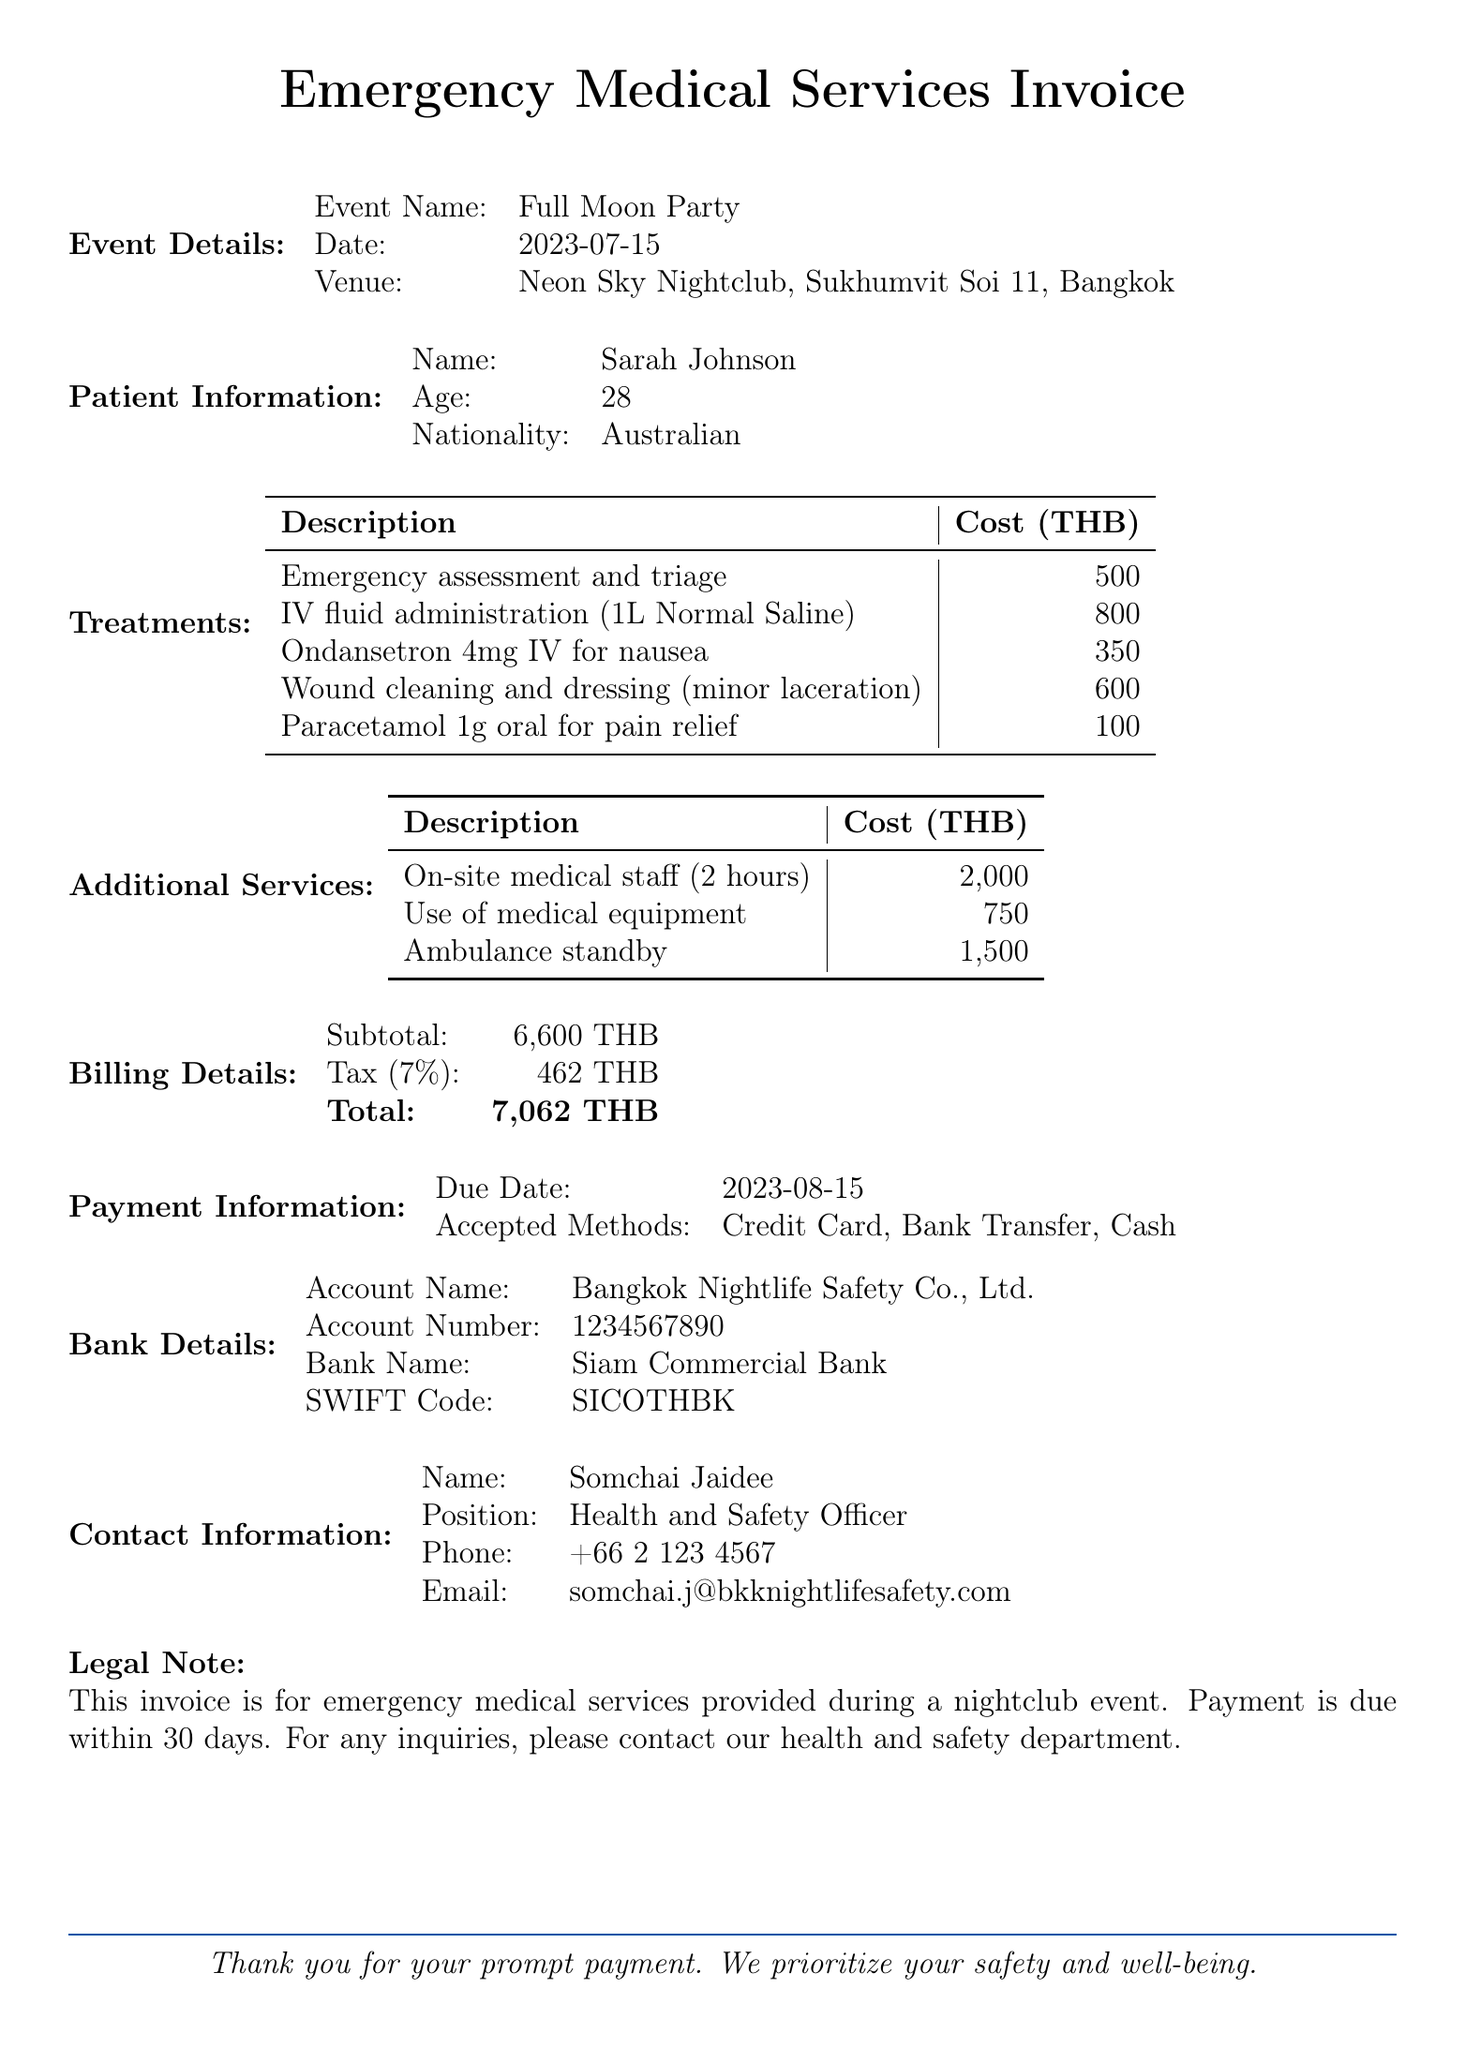What is the name of the event? The event name is specified in the document under Event Details.
Answer: Full Moon Party Who is the patient? The patient's name is provided in the Patient Information section of the document.
Answer: Sarah Johnson What is the total amount due? The total amount due is listed under Billing Details in the document.
Answer: 7062 THB What is the due date for payment? The due date is mentioned in the Payment Information section of the document.
Answer: 2023-08-15 How much was charged for ambulance standby? The cost for ambulance standby is found under Additional Services in the document.
Answer: 1500 THB What treatments were provided? The specific treatments are detailed in the Treatments section of the document.
Answer: Emergency assessment and triage, IV fluid administration, Ondansetron for nausea, Wound cleaning, Paracetamol for pain relief How many hours of on-site medical staff were provided? The duration of on-site medical staff service is specified in the Additional Services section.
Answer: 2 hours What organization issued the invoice? The company issuing the invoice is mentioned at the top of the document.
Answer: Bangkok Nightlife Safety Co., Ltd 